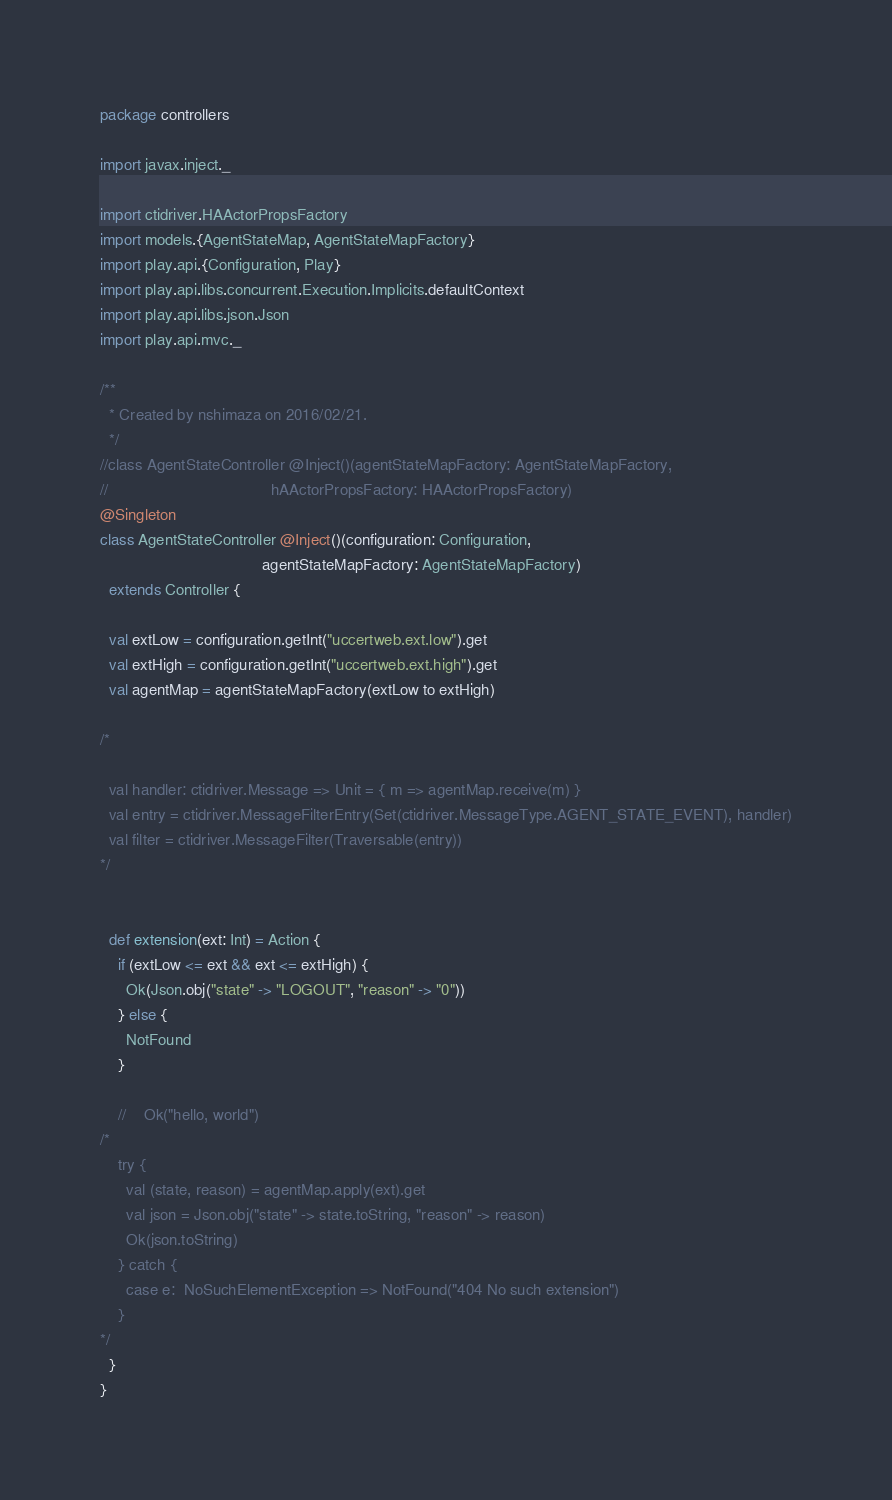Convert code to text. <code><loc_0><loc_0><loc_500><loc_500><_Scala_>package controllers

import javax.inject._

import ctidriver.HAActorPropsFactory
import models.{AgentStateMap, AgentStateMapFactory}
import play.api.{Configuration, Play}
import play.api.libs.concurrent.Execution.Implicits.defaultContext
import play.api.libs.json.Json
import play.api.mvc._

/**
  * Created by nshimaza on 2016/02/21.
  */
//class AgentStateController @Inject()(agentStateMapFactory: AgentStateMapFactory,
//                                     hAActorPropsFactory: HAActorPropsFactory)
@Singleton
class AgentStateController @Inject()(configuration: Configuration,
                                     agentStateMapFactory: AgentStateMapFactory)
  extends Controller {

  val extLow = configuration.getInt("uccertweb.ext.low").get
  val extHigh = configuration.getInt("uccertweb.ext.high").get
  val agentMap = agentStateMapFactory(extLow to extHigh)

/*

  val handler: ctidriver.Message => Unit = { m => agentMap.receive(m) }
  val entry = ctidriver.MessageFilterEntry(Set(ctidriver.MessageType.AGENT_STATE_EVENT), handler)
  val filter = ctidriver.MessageFilter(Traversable(entry))
*/


  def extension(ext: Int) = Action {
    if (extLow <= ext && ext <= extHigh) {
      Ok(Json.obj("state" -> "LOGOUT", "reason" -> "0"))
    } else {
      NotFound
    }

    //    Ok("hello, world")
/*
    try {
      val (state, reason) = agentMap.apply(ext).get
      val json = Json.obj("state" -> state.toString, "reason" -> reason)
      Ok(json.toString)
    } catch {
      case e:  NoSuchElementException => NotFound("404 No such extension")
    }
*/
  }
}
</code> 